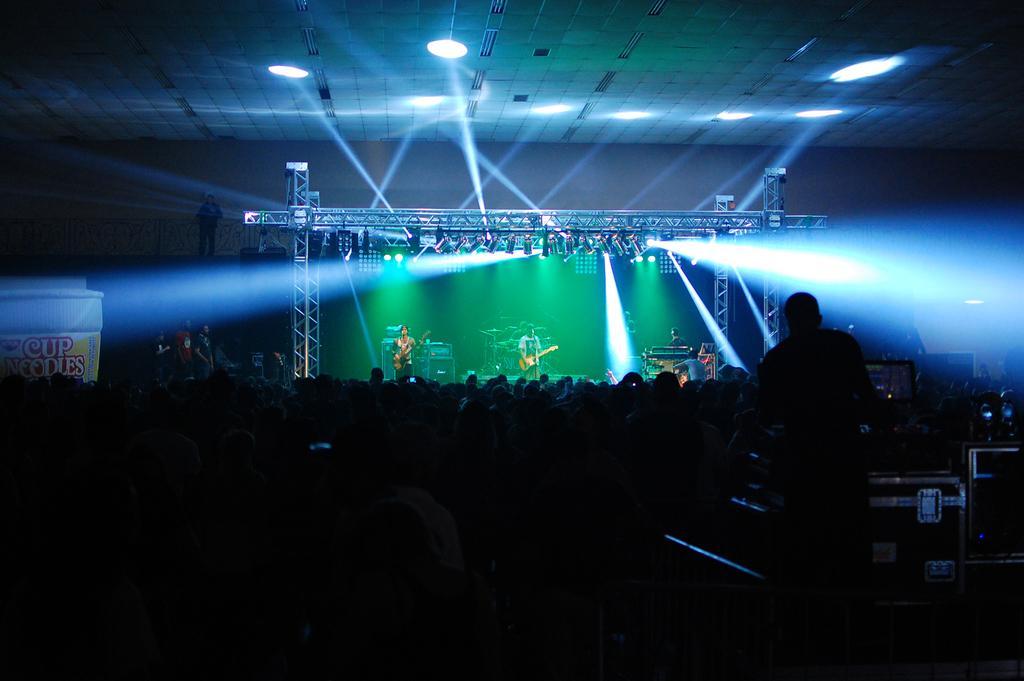Can you describe this image briefly? In the center of the image we can see persons performing on dais. At the bottom of the days we can see crowd. In the background there are lights, persons and wall. 